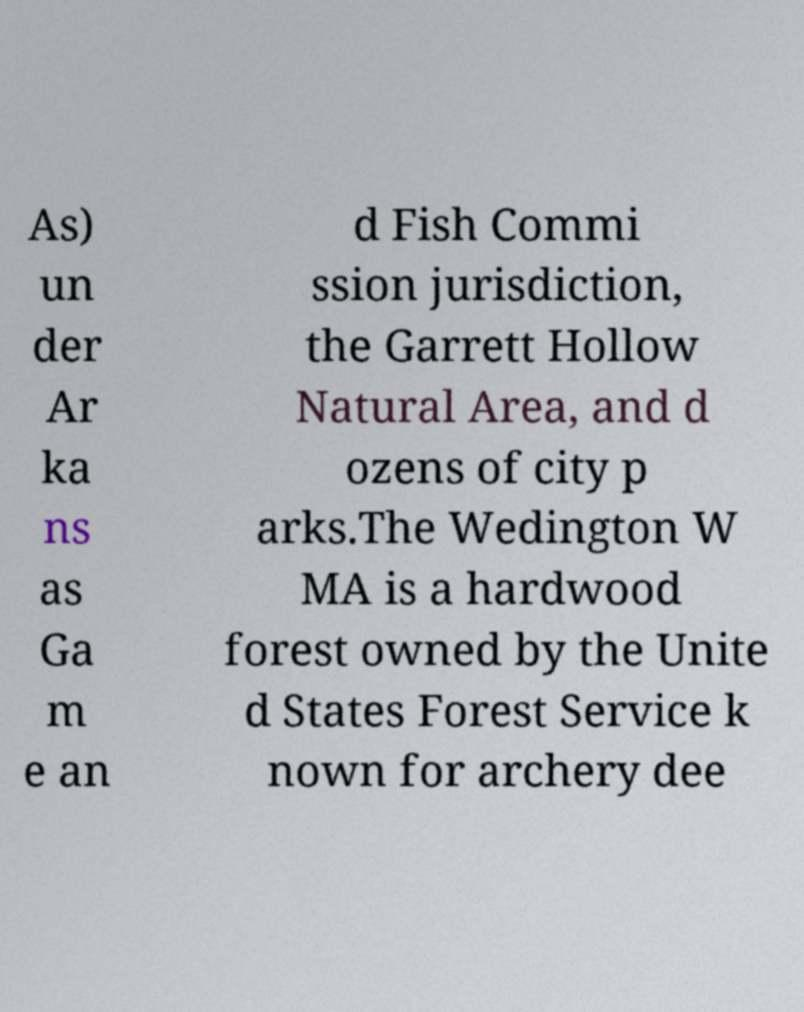What messages or text are displayed in this image? I need them in a readable, typed format. As) un der Ar ka ns as Ga m e an d Fish Commi ssion jurisdiction, the Garrett Hollow Natural Area, and d ozens of city p arks.The Wedington W MA is a hardwood forest owned by the Unite d States Forest Service k nown for archery dee 